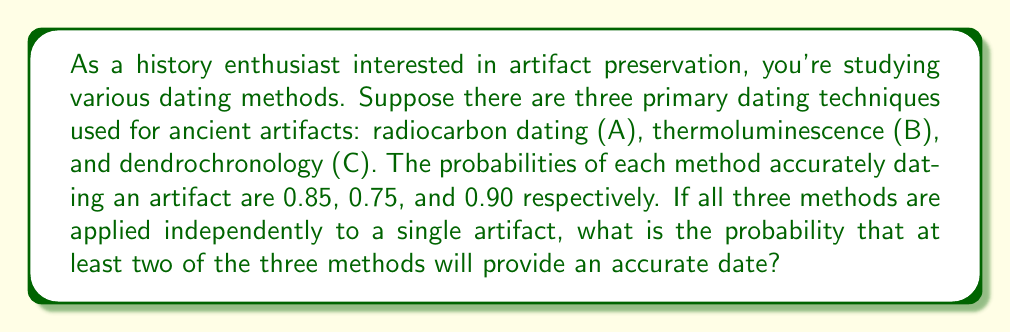Give your solution to this math problem. Let's approach this step-by-step:

1) First, we need to calculate the probability of each possible combination of accurate results:

   P(All three accurate) = P(A) × P(B) × P(C)
   $$ P(\text{All three}) = 0.85 \times 0.75 \times 0.90 = 0.57375 $$

2) Now, let's calculate the probability of exactly two methods being accurate:

   P(A and B accurate, C inaccurate) = P(A) × P(B) × (1 - P(C))
   $$ P(AB) = 0.85 \times 0.75 \times 0.10 = 0.06375 $$

   P(A and C accurate, B inaccurate) = P(A) × (1 - P(B)) × P(C)
   $$ P(AC) = 0.85 \times 0.25 \times 0.90 = 0.19125 $$

   P(B and C accurate, A inaccurate) = (1 - P(A)) × P(B) × P(C)
   $$ P(BC) = 0.15 \times 0.75 \times 0.90 = 0.10125 $$

3) The probability of at least two methods being accurate is the sum of the probability of all three being accurate and the probabilities of exactly two being accurate:

   $$ P(\text{at least two accurate}) = P(\text{All three}) + P(AB) + P(AC) + P(BC) $$
   $$ = 0.57375 + 0.06375 + 0.19125 + 0.10125 $$
   $$ = 0.93 $$

Therefore, the probability that at least two of the three methods will provide an accurate date is 0.93 or 93%.
Answer: 0.93 